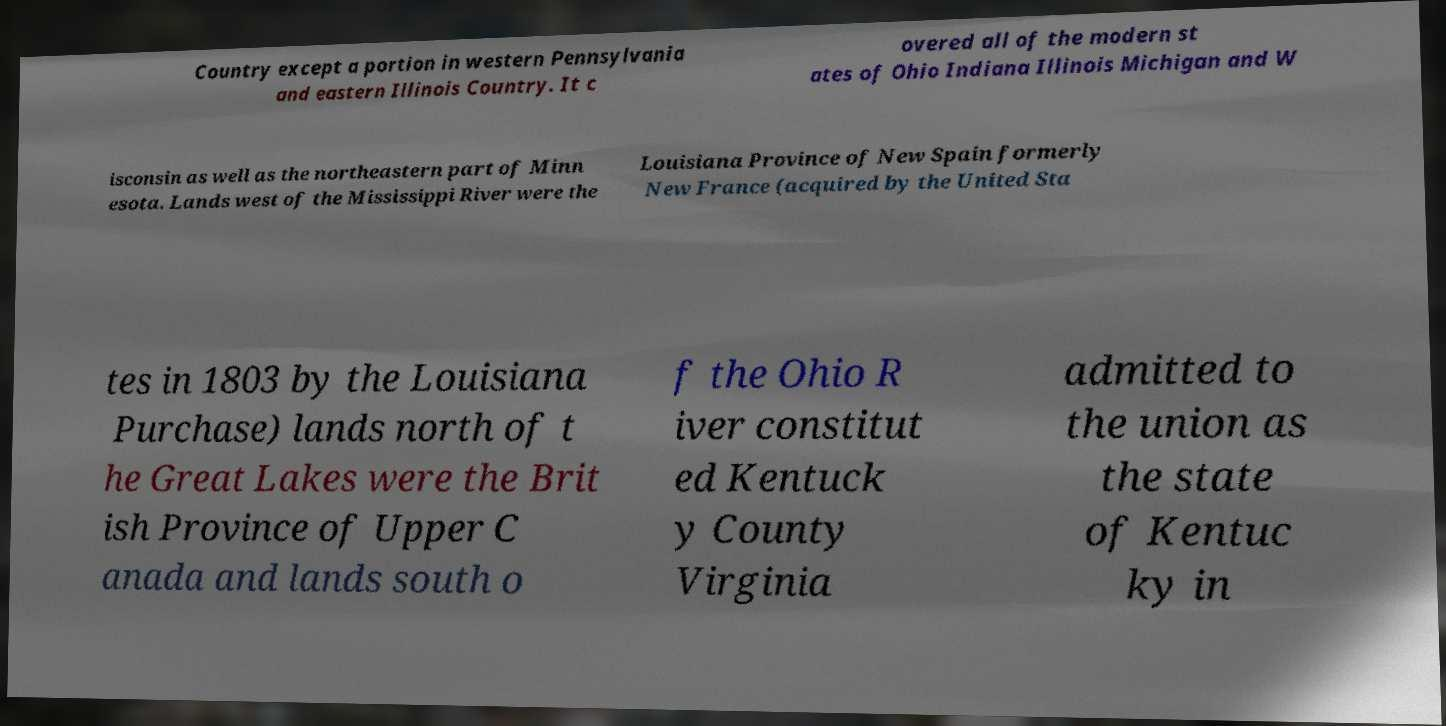There's text embedded in this image that I need extracted. Can you transcribe it verbatim? Country except a portion in western Pennsylvania and eastern Illinois Country. It c overed all of the modern st ates of Ohio Indiana Illinois Michigan and W isconsin as well as the northeastern part of Minn esota. Lands west of the Mississippi River were the Louisiana Province of New Spain formerly New France (acquired by the United Sta tes in 1803 by the Louisiana Purchase) lands north of t he Great Lakes were the Brit ish Province of Upper C anada and lands south o f the Ohio R iver constitut ed Kentuck y County Virginia admitted to the union as the state of Kentuc ky in 